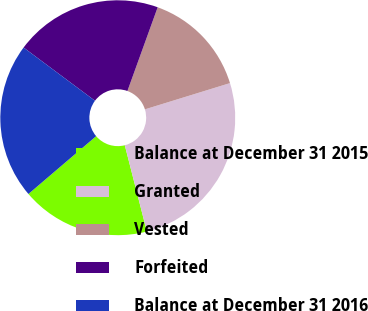Convert chart. <chart><loc_0><loc_0><loc_500><loc_500><pie_chart><fcel>Balance at December 31 2015<fcel>Granted<fcel>Vested<fcel>Forfeited<fcel>Balance at December 31 2016<nl><fcel>17.74%<fcel>25.78%<fcel>14.72%<fcel>20.33%<fcel>21.44%<nl></chart> 